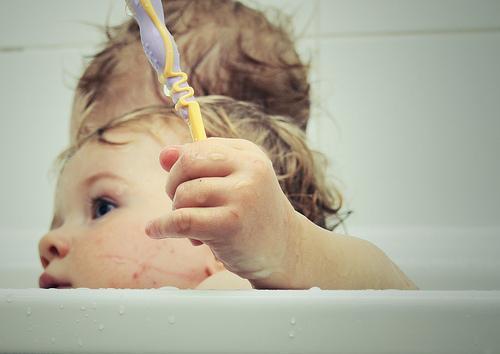What is the baby sitting holding?
Answer the question by selecting the correct answer among the 4 following choices.
Options: Apple, pumpkin, toothbrush, his foot. Toothbrush. 